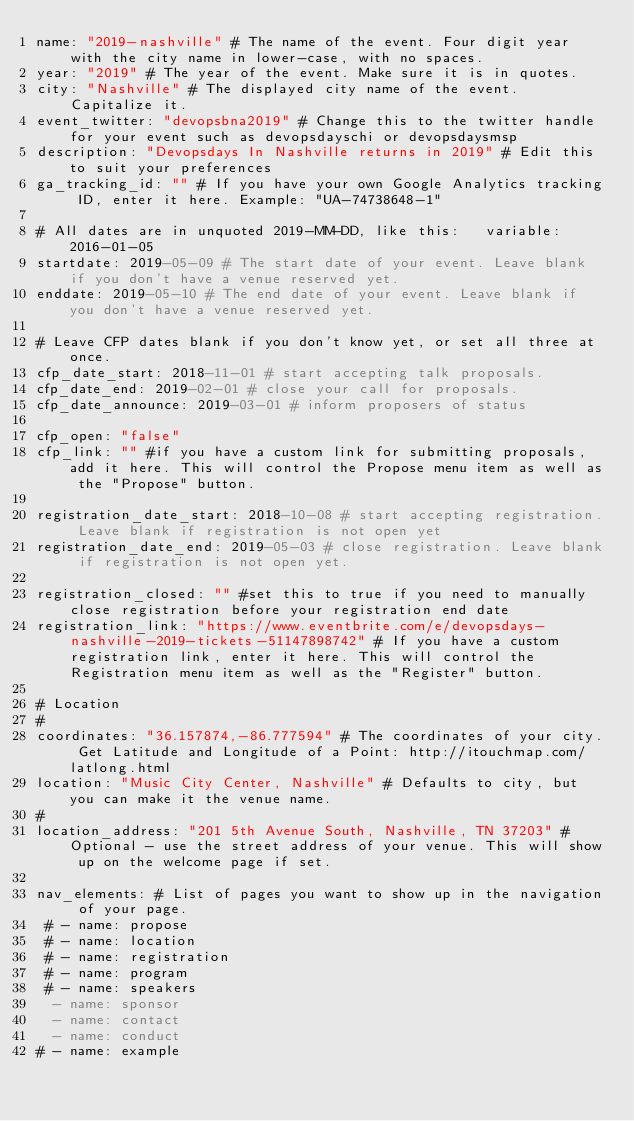<code> <loc_0><loc_0><loc_500><loc_500><_YAML_>name: "2019-nashville" # The name of the event. Four digit year with the city name in lower-case, with no spaces.
year: "2019" # The year of the event. Make sure it is in quotes.
city: "Nashville" # The displayed city name of the event. Capitalize it.
event_twitter: "devopsbna2019" # Change this to the twitter handle for your event such as devopsdayschi or devopsdaysmsp
description: "Devopsdays In Nashville returns in 2019" # Edit this to suit your preferences
ga_tracking_id: "" # If you have your own Google Analytics tracking ID, enter it here. Example: "UA-74738648-1"

# All dates are in unquoted 2019-MM-DD, like this:   variable: 2016-01-05
startdate: 2019-05-09 # The start date of your event. Leave blank if you don't have a venue reserved yet.
enddate: 2019-05-10 # The end date of your event. Leave blank if you don't have a venue reserved yet.

# Leave CFP dates blank if you don't know yet, or set all three at once.
cfp_date_start: 2018-11-01 # start accepting talk proposals.
cfp_date_end: 2019-02-01 # close your call for proposals.
cfp_date_announce: 2019-03-01 # inform proposers of status

cfp_open: "false"
cfp_link: "" #if you have a custom link for submitting proposals, add it here. This will control the Propose menu item as well as the "Propose" button.

registration_date_start: 2018-10-08 # start accepting registration. Leave blank if registration is not open yet
registration_date_end: 2019-05-03 # close registration. Leave blank if registration is not open yet.

registration_closed: "" #set this to true if you need to manually close registration before your registration end date
registration_link: "https://www.eventbrite.com/e/devopsdays-nashville-2019-tickets-51147898742" # If you have a custom registration link, enter it here. This will control the Registration menu item as well as the "Register" button.

# Location
#
coordinates: "36.157874,-86.777594" # The coordinates of your city. Get Latitude and Longitude of a Point: http://itouchmap.com/latlong.html
location: "Music City Center, Nashville" # Defaults to city, but you can make it the venue name.
#
location_address: "201 5th Avenue South, Nashville, TN 37203" #Optional - use the street address of your venue. This will show up on the welcome page if set.

nav_elements: # List of pages you want to show up in the navigation of your page.
 # - name: propose
 # - name: location
 # - name: registration
 # - name: program
 # - name: speakers
  - name: sponsor
  - name: contact
  - name: conduct
# - name: example</code> 